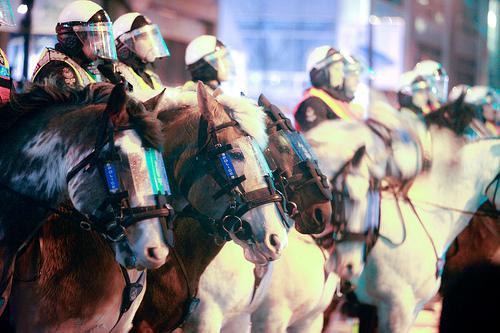Question: what are the policemen wearing on their heads?
Choices:
A. Hats.
B. Helmets.
C. Caps.
D. Headbands.
Answer with the letter. Answer: B Question: what material is covering the horse's eyes?
Choices:
A. Plastic.
B. Leather.
C. Cloth.
D. Paper.
Answer with the letter. Answer: A Question: who is riding the horses?
Choices:
A. Cowboy.
B. Rancher.
C. Equestrian.
D. Police.
Answer with the letter. Answer: D Question: what color are the police shirts?
Choices:
A. Black.
B. Blue.
C. White.
D. Red.
Answer with the letter. Answer: A Question: what color are the police tags on the horses face?
Choices:
A. Black.
B. Blue.
C. Brown.
D. Yellow.
Answer with the letter. Answer: B Question: why are the police wearing helmets?
Choices:
A. For dress rehearsal.
B. For a funeral.
C. For a celebration.
D. For protection.
Answer with the letter. Answer: D 